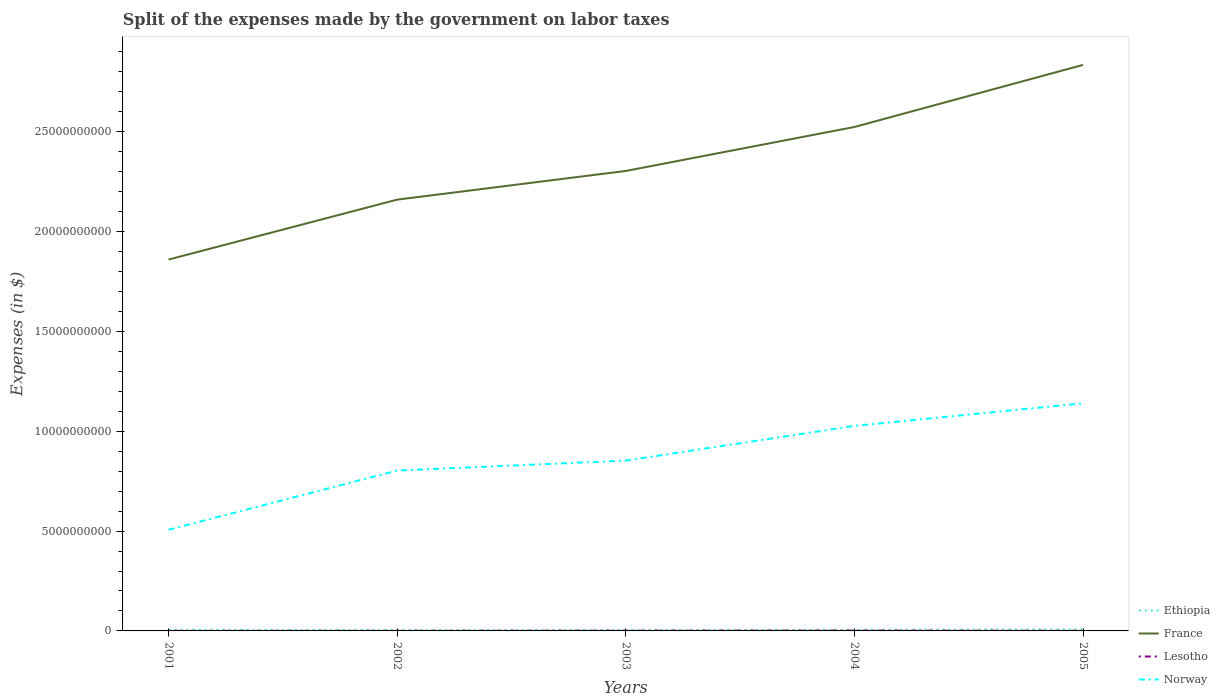How many different coloured lines are there?
Provide a succinct answer. 4. Across all years, what is the maximum expenses made by the government on labor taxes in Norway?
Offer a terse response. 5.07e+09. What is the total expenses made by the government on labor taxes in Ethiopia in the graph?
Provide a short and direct response. -2.00e+07. What is the difference between the highest and the second highest expenses made by the government on labor taxes in Norway?
Your answer should be compact. 6.34e+09. What is the difference between the highest and the lowest expenses made by the government on labor taxes in France?
Provide a short and direct response. 2. Is the expenses made by the government on labor taxes in Ethiopia strictly greater than the expenses made by the government on labor taxes in Norway over the years?
Ensure brevity in your answer.  Yes. How many lines are there?
Provide a short and direct response. 4. Does the graph contain any zero values?
Your answer should be compact. No. Does the graph contain grids?
Make the answer very short. No. Where does the legend appear in the graph?
Provide a short and direct response. Bottom right. How many legend labels are there?
Your answer should be compact. 4. What is the title of the graph?
Offer a very short reply. Split of the expenses made by the government on labor taxes. What is the label or title of the X-axis?
Your response must be concise. Years. What is the label or title of the Y-axis?
Your response must be concise. Expenses (in $). What is the Expenses (in $) in Ethiopia in 2001?
Keep it short and to the point. 5.79e+07. What is the Expenses (in $) of France in 2001?
Your response must be concise. 1.86e+1. What is the Expenses (in $) of Lesotho in 2001?
Ensure brevity in your answer.  5.30e+06. What is the Expenses (in $) of Norway in 2001?
Your response must be concise. 5.07e+09. What is the Expenses (in $) in Ethiopia in 2002?
Ensure brevity in your answer.  4.51e+07. What is the Expenses (in $) in France in 2002?
Ensure brevity in your answer.  2.16e+1. What is the Expenses (in $) in Lesotho in 2002?
Your response must be concise. 6.40e+06. What is the Expenses (in $) in Norway in 2002?
Offer a very short reply. 8.03e+09. What is the Expenses (in $) in Ethiopia in 2003?
Ensure brevity in your answer.  5.20e+07. What is the Expenses (in $) of France in 2003?
Offer a terse response. 2.30e+1. What is the Expenses (in $) of Lesotho in 2003?
Your answer should be compact. 1.05e+07. What is the Expenses (in $) in Norway in 2003?
Your answer should be very brief. 8.53e+09. What is the Expenses (in $) in Ethiopia in 2004?
Provide a succinct answer. 5.71e+07. What is the Expenses (in $) of France in 2004?
Ensure brevity in your answer.  2.52e+1. What is the Expenses (in $) in Lesotho in 2004?
Give a very brief answer. 1.78e+07. What is the Expenses (in $) in Norway in 2004?
Provide a succinct answer. 1.03e+1. What is the Expenses (in $) in Ethiopia in 2005?
Your answer should be very brief. 7.71e+07. What is the Expenses (in $) of France in 2005?
Provide a succinct answer. 2.84e+1. What is the Expenses (in $) of Lesotho in 2005?
Offer a very short reply. 6.74e+06. What is the Expenses (in $) in Norway in 2005?
Ensure brevity in your answer.  1.14e+1. Across all years, what is the maximum Expenses (in $) in Ethiopia?
Your answer should be compact. 7.71e+07. Across all years, what is the maximum Expenses (in $) of France?
Offer a very short reply. 2.84e+1. Across all years, what is the maximum Expenses (in $) of Lesotho?
Your answer should be compact. 1.78e+07. Across all years, what is the maximum Expenses (in $) of Norway?
Offer a terse response. 1.14e+1. Across all years, what is the minimum Expenses (in $) in Ethiopia?
Keep it short and to the point. 4.51e+07. Across all years, what is the minimum Expenses (in $) in France?
Your answer should be very brief. 1.86e+1. Across all years, what is the minimum Expenses (in $) of Lesotho?
Your answer should be compact. 5.30e+06. Across all years, what is the minimum Expenses (in $) in Norway?
Keep it short and to the point. 5.07e+09. What is the total Expenses (in $) of Ethiopia in the graph?
Provide a succinct answer. 2.89e+08. What is the total Expenses (in $) of France in the graph?
Offer a very short reply. 1.17e+11. What is the total Expenses (in $) in Lesotho in the graph?
Your answer should be compact. 4.67e+07. What is the total Expenses (in $) in Norway in the graph?
Offer a very short reply. 4.33e+1. What is the difference between the Expenses (in $) of Ethiopia in 2001 and that in 2002?
Provide a short and direct response. 1.28e+07. What is the difference between the Expenses (in $) of France in 2001 and that in 2002?
Offer a very short reply. -3.00e+09. What is the difference between the Expenses (in $) of Lesotho in 2001 and that in 2002?
Provide a short and direct response. -1.10e+06. What is the difference between the Expenses (in $) of Norway in 2001 and that in 2002?
Your answer should be compact. -2.97e+09. What is the difference between the Expenses (in $) in Ethiopia in 2001 and that in 2003?
Provide a succinct answer. 5.90e+06. What is the difference between the Expenses (in $) in France in 2001 and that in 2003?
Give a very brief answer. -4.44e+09. What is the difference between the Expenses (in $) in Lesotho in 2001 and that in 2003?
Provide a succinct answer. -5.18e+06. What is the difference between the Expenses (in $) in Norway in 2001 and that in 2003?
Offer a very short reply. -3.46e+09. What is the difference between the Expenses (in $) in France in 2001 and that in 2004?
Provide a succinct answer. -6.64e+09. What is the difference between the Expenses (in $) of Lesotho in 2001 and that in 2004?
Offer a terse response. -1.25e+07. What is the difference between the Expenses (in $) of Norway in 2001 and that in 2004?
Your answer should be compact. -5.20e+09. What is the difference between the Expenses (in $) of Ethiopia in 2001 and that in 2005?
Provide a succinct answer. -1.92e+07. What is the difference between the Expenses (in $) in France in 2001 and that in 2005?
Your answer should be compact. -9.75e+09. What is the difference between the Expenses (in $) of Lesotho in 2001 and that in 2005?
Provide a succinct answer. -1.44e+06. What is the difference between the Expenses (in $) of Norway in 2001 and that in 2005?
Your answer should be compact. -6.34e+09. What is the difference between the Expenses (in $) of Ethiopia in 2002 and that in 2003?
Your answer should be very brief. -6.90e+06. What is the difference between the Expenses (in $) in France in 2002 and that in 2003?
Your response must be concise. -1.44e+09. What is the difference between the Expenses (in $) in Lesotho in 2002 and that in 2003?
Ensure brevity in your answer.  -4.08e+06. What is the difference between the Expenses (in $) in Norway in 2002 and that in 2003?
Give a very brief answer. -4.99e+08. What is the difference between the Expenses (in $) of Ethiopia in 2002 and that in 2004?
Your answer should be compact. -1.20e+07. What is the difference between the Expenses (in $) of France in 2002 and that in 2004?
Offer a very short reply. -3.64e+09. What is the difference between the Expenses (in $) in Lesotho in 2002 and that in 2004?
Make the answer very short. -1.14e+07. What is the difference between the Expenses (in $) in Norway in 2002 and that in 2004?
Your answer should be very brief. -2.24e+09. What is the difference between the Expenses (in $) of Ethiopia in 2002 and that in 2005?
Provide a succinct answer. -3.20e+07. What is the difference between the Expenses (in $) in France in 2002 and that in 2005?
Offer a very short reply. -6.75e+09. What is the difference between the Expenses (in $) of Lesotho in 2002 and that in 2005?
Offer a very short reply. -3.35e+05. What is the difference between the Expenses (in $) of Norway in 2002 and that in 2005?
Offer a terse response. -3.37e+09. What is the difference between the Expenses (in $) in Ethiopia in 2003 and that in 2004?
Your answer should be very brief. -5.10e+06. What is the difference between the Expenses (in $) of France in 2003 and that in 2004?
Your answer should be compact. -2.20e+09. What is the difference between the Expenses (in $) of Lesotho in 2003 and that in 2004?
Provide a short and direct response. -7.32e+06. What is the difference between the Expenses (in $) in Norway in 2003 and that in 2004?
Provide a short and direct response. -1.74e+09. What is the difference between the Expenses (in $) in Ethiopia in 2003 and that in 2005?
Give a very brief answer. -2.51e+07. What is the difference between the Expenses (in $) in France in 2003 and that in 2005?
Offer a very short reply. -5.31e+09. What is the difference between the Expenses (in $) of Lesotho in 2003 and that in 2005?
Keep it short and to the point. 3.74e+06. What is the difference between the Expenses (in $) of Norway in 2003 and that in 2005?
Keep it short and to the point. -2.87e+09. What is the difference between the Expenses (in $) in Ethiopia in 2004 and that in 2005?
Provide a short and direct response. -2.00e+07. What is the difference between the Expenses (in $) in France in 2004 and that in 2005?
Give a very brief answer. -3.11e+09. What is the difference between the Expenses (in $) of Lesotho in 2004 and that in 2005?
Ensure brevity in your answer.  1.11e+07. What is the difference between the Expenses (in $) in Norway in 2004 and that in 2005?
Your answer should be very brief. -1.13e+09. What is the difference between the Expenses (in $) in Ethiopia in 2001 and the Expenses (in $) in France in 2002?
Your answer should be very brief. -2.15e+1. What is the difference between the Expenses (in $) in Ethiopia in 2001 and the Expenses (in $) in Lesotho in 2002?
Your answer should be very brief. 5.15e+07. What is the difference between the Expenses (in $) in Ethiopia in 2001 and the Expenses (in $) in Norway in 2002?
Give a very brief answer. -7.98e+09. What is the difference between the Expenses (in $) in France in 2001 and the Expenses (in $) in Lesotho in 2002?
Make the answer very short. 1.86e+1. What is the difference between the Expenses (in $) in France in 2001 and the Expenses (in $) in Norway in 2002?
Offer a terse response. 1.06e+1. What is the difference between the Expenses (in $) of Lesotho in 2001 and the Expenses (in $) of Norway in 2002?
Give a very brief answer. -8.03e+09. What is the difference between the Expenses (in $) of Ethiopia in 2001 and the Expenses (in $) of France in 2003?
Give a very brief answer. -2.30e+1. What is the difference between the Expenses (in $) in Ethiopia in 2001 and the Expenses (in $) in Lesotho in 2003?
Provide a short and direct response. 4.74e+07. What is the difference between the Expenses (in $) in Ethiopia in 2001 and the Expenses (in $) in Norway in 2003?
Offer a very short reply. -8.47e+09. What is the difference between the Expenses (in $) of France in 2001 and the Expenses (in $) of Lesotho in 2003?
Offer a terse response. 1.86e+1. What is the difference between the Expenses (in $) of France in 2001 and the Expenses (in $) of Norway in 2003?
Offer a terse response. 1.01e+1. What is the difference between the Expenses (in $) in Lesotho in 2001 and the Expenses (in $) in Norway in 2003?
Offer a very short reply. -8.53e+09. What is the difference between the Expenses (in $) in Ethiopia in 2001 and the Expenses (in $) in France in 2004?
Give a very brief answer. -2.52e+1. What is the difference between the Expenses (in $) of Ethiopia in 2001 and the Expenses (in $) of Lesotho in 2004?
Make the answer very short. 4.01e+07. What is the difference between the Expenses (in $) in Ethiopia in 2001 and the Expenses (in $) in Norway in 2004?
Offer a terse response. -1.02e+1. What is the difference between the Expenses (in $) in France in 2001 and the Expenses (in $) in Lesotho in 2004?
Your answer should be very brief. 1.86e+1. What is the difference between the Expenses (in $) in France in 2001 and the Expenses (in $) in Norway in 2004?
Your answer should be compact. 8.33e+09. What is the difference between the Expenses (in $) of Lesotho in 2001 and the Expenses (in $) of Norway in 2004?
Make the answer very short. -1.03e+1. What is the difference between the Expenses (in $) of Ethiopia in 2001 and the Expenses (in $) of France in 2005?
Give a very brief answer. -2.83e+1. What is the difference between the Expenses (in $) in Ethiopia in 2001 and the Expenses (in $) in Lesotho in 2005?
Make the answer very short. 5.12e+07. What is the difference between the Expenses (in $) of Ethiopia in 2001 and the Expenses (in $) of Norway in 2005?
Ensure brevity in your answer.  -1.13e+1. What is the difference between the Expenses (in $) in France in 2001 and the Expenses (in $) in Lesotho in 2005?
Provide a succinct answer. 1.86e+1. What is the difference between the Expenses (in $) in France in 2001 and the Expenses (in $) in Norway in 2005?
Provide a short and direct response. 7.20e+09. What is the difference between the Expenses (in $) in Lesotho in 2001 and the Expenses (in $) in Norway in 2005?
Provide a short and direct response. -1.14e+1. What is the difference between the Expenses (in $) in Ethiopia in 2002 and the Expenses (in $) in France in 2003?
Your answer should be very brief. -2.30e+1. What is the difference between the Expenses (in $) of Ethiopia in 2002 and the Expenses (in $) of Lesotho in 2003?
Ensure brevity in your answer.  3.46e+07. What is the difference between the Expenses (in $) of Ethiopia in 2002 and the Expenses (in $) of Norway in 2003?
Give a very brief answer. -8.49e+09. What is the difference between the Expenses (in $) of France in 2002 and the Expenses (in $) of Lesotho in 2003?
Your answer should be very brief. 2.16e+1. What is the difference between the Expenses (in $) of France in 2002 and the Expenses (in $) of Norway in 2003?
Provide a succinct answer. 1.31e+1. What is the difference between the Expenses (in $) of Lesotho in 2002 and the Expenses (in $) of Norway in 2003?
Your answer should be very brief. -8.53e+09. What is the difference between the Expenses (in $) of Ethiopia in 2002 and the Expenses (in $) of France in 2004?
Offer a terse response. -2.52e+1. What is the difference between the Expenses (in $) in Ethiopia in 2002 and the Expenses (in $) in Lesotho in 2004?
Keep it short and to the point. 2.73e+07. What is the difference between the Expenses (in $) in Ethiopia in 2002 and the Expenses (in $) in Norway in 2004?
Provide a short and direct response. -1.02e+1. What is the difference between the Expenses (in $) of France in 2002 and the Expenses (in $) of Lesotho in 2004?
Your answer should be compact. 2.16e+1. What is the difference between the Expenses (in $) of France in 2002 and the Expenses (in $) of Norway in 2004?
Offer a terse response. 1.13e+1. What is the difference between the Expenses (in $) in Lesotho in 2002 and the Expenses (in $) in Norway in 2004?
Make the answer very short. -1.03e+1. What is the difference between the Expenses (in $) of Ethiopia in 2002 and the Expenses (in $) of France in 2005?
Keep it short and to the point. -2.83e+1. What is the difference between the Expenses (in $) of Ethiopia in 2002 and the Expenses (in $) of Lesotho in 2005?
Your response must be concise. 3.84e+07. What is the difference between the Expenses (in $) of Ethiopia in 2002 and the Expenses (in $) of Norway in 2005?
Offer a very short reply. -1.14e+1. What is the difference between the Expenses (in $) of France in 2002 and the Expenses (in $) of Lesotho in 2005?
Make the answer very short. 2.16e+1. What is the difference between the Expenses (in $) of France in 2002 and the Expenses (in $) of Norway in 2005?
Provide a short and direct response. 1.02e+1. What is the difference between the Expenses (in $) of Lesotho in 2002 and the Expenses (in $) of Norway in 2005?
Give a very brief answer. -1.14e+1. What is the difference between the Expenses (in $) of Ethiopia in 2003 and the Expenses (in $) of France in 2004?
Ensure brevity in your answer.  -2.52e+1. What is the difference between the Expenses (in $) of Ethiopia in 2003 and the Expenses (in $) of Lesotho in 2004?
Make the answer very short. 3.42e+07. What is the difference between the Expenses (in $) in Ethiopia in 2003 and the Expenses (in $) in Norway in 2004?
Your answer should be very brief. -1.02e+1. What is the difference between the Expenses (in $) in France in 2003 and the Expenses (in $) in Lesotho in 2004?
Provide a succinct answer. 2.30e+1. What is the difference between the Expenses (in $) of France in 2003 and the Expenses (in $) of Norway in 2004?
Make the answer very short. 1.28e+1. What is the difference between the Expenses (in $) in Lesotho in 2003 and the Expenses (in $) in Norway in 2004?
Offer a very short reply. -1.03e+1. What is the difference between the Expenses (in $) in Ethiopia in 2003 and the Expenses (in $) in France in 2005?
Provide a short and direct response. -2.83e+1. What is the difference between the Expenses (in $) in Ethiopia in 2003 and the Expenses (in $) in Lesotho in 2005?
Offer a very short reply. 4.53e+07. What is the difference between the Expenses (in $) of Ethiopia in 2003 and the Expenses (in $) of Norway in 2005?
Provide a short and direct response. -1.14e+1. What is the difference between the Expenses (in $) in France in 2003 and the Expenses (in $) in Lesotho in 2005?
Your answer should be very brief. 2.30e+1. What is the difference between the Expenses (in $) of France in 2003 and the Expenses (in $) of Norway in 2005?
Your answer should be very brief. 1.16e+1. What is the difference between the Expenses (in $) of Lesotho in 2003 and the Expenses (in $) of Norway in 2005?
Provide a short and direct response. -1.14e+1. What is the difference between the Expenses (in $) in Ethiopia in 2004 and the Expenses (in $) in France in 2005?
Offer a very short reply. -2.83e+1. What is the difference between the Expenses (in $) in Ethiopia in 2004 and the Expenses (in $) in Lesotho in 2005?
Your response must be concise. 5.04e+07. What is the difference between the Expenses (in $) of Ethiopia in 2004 and the Expenses (in $) of Norway in 2005?
Your answer should be very brief. -1.13e+1. What is the difference between the Expenses (in $) in France in 2004 and the Expenses (in $) in Lesotho in 2005?
Provide a short and direct response. 2.52e+1. What is the difference between the Expenses (in $) of France in 2004 and the Expenses (in $) of Norway in 2005?
Your answer should be compact. 1.38e+1. What is the difference between the Expenses (in $) of Lesotho in 2004 and the Expenses (in $) of Norway in 2005?
Your answer should be very brief. -1.14e+1. What is the average Expenses (in $) of Ethiopia per year?
Offer a terse response. 5.78e+07. What is the average Expenses (in $) of France per year?
Ensure brevity in your answer.  2.34e+1. What is the average Expenses (in $) in Lesotho per year?
Your answer should be compact. 9.34e+06. What is the average Expenses (in $) of Norway per year?
Make the answer very short. 8.66e+09. In the year 2001, what is the difference between the Expenses (in $) of Ethiopia and Expenses (in $) of France?
Your answer should be very brief. -1.85e+1. In the year 2001, what is the difference between the Expenses (in $) of Ethiopia and Expenses (in $) of Lesotho?
Your answer should be very brief. 5.26e+07. In the year 2001, what is the difference between the Expenses (in $) of Ethiopia and Expenses (in $) of Norway?
Offer a very short reply. -5.01e+09. In the year 2001, what is the difference between the Expenses (in $) of France and Expenses (in $) of Lesotho?
Provide a succinct answer. 1.86e+1. In the year 2001, what is the difference between the Expenses (in $) in France and Expenses (in $) in Norway?
Make the answer very short. 1.35e+1. In the year 2001, what is the difference between the Expenses (in $) in Lesotho and Expenses (in $) in Norway?
Offer a very short reply. -5.06e+09. In the year 2002, what is the difference between the Expenses (in $) in Ethiopia and Expenses (in $) in France?
Your answer should be compact. -2.16e+1. In the year 2002, what is the difference between the Expenses (in $) of Ethiopia and Expenses (in $) of Lesotho?
Keep it short and to the point. 3.87e+07. In the year 2002, what is the difference between the Expenses (in $) in Ethiopia and Expenses (in $) in Norway?
Give a very brief answer. -7.99e+09. In the year 2002, what is the difference between the Expenses (in $) of France and Expenses (in $) of Lesotho?
Your response must be concise. 2.16e+1. In the year 2002, what is the difference between the Expenses (in $) in France and Expenses (in $) in Norway?
Make the answer very short. 1.36e+1. In the year 2002, what is the difference between the Expenses (in $) in Lesotho and Expenses (in $) in Norway?
Your response must be concise. -8.03e+09. In the year 2003, what is the difference between the Expenses (in $) in Ethiopia and Expenses (in $) in France?
Offer a very short reply. -2.30e+1. In the year 2003, what is the difference between the Expenses (in $) of Ethiopia and Expenses (in $) of Lesotho?
Provide a succinct answer. 4.15e+07. In the year 2003, what is the difference between the Expenses (in $) of Ethiopia and Expenses (in $) of Norway?
Keep it short and to the point. -8.48e+09. In the year 2003, what is the difference between the Expenses (in $) of France and Expenses (in $) of Lesotho?
Ensure brevity in your answer.  2.30e+1. In the year 2003, what is the difference between the Expenses (in $) of France and Expenses (in $) of Norway?
Make the answer very short. 1.45e+1. In the year 2003, what is the difference between the Expenses (in $) of Lesotho and Expenses (in $) of Norway?
Provide a short and direct response. -8.52e+09. In the year 2004, what is the difference between the Expenses (in $) of Ethiopia and Expenses (in $) of France?
Provide a succinct answer. -2.52e+1. In the year 2004, what is the difference between the Expenses (in $) in Ethiopia and Expenses (in $) in Lesotho?
Make the answer very short. 3.93e+07. In the year 2004, what is the difference between the Expenses (in $) in Ethiopia and Expenses (in $) in Norway?
Keep it short and to the point. -1.02e+1. In the year 2004, what is the difference between the Expenses (in $) of France and Expenses (in $) of Lesotho?
Your answer should be very brief. 2.52e+1. In the year 2004, what is the difference between the Expenses (in $) of France and Expenses (in $) of Norway?
Provide a succinct answer. 1.50e+1. In the year 2004, what is the difference between the Expenses (in $) of Lesotho and Expenses (in $) of Norway?
Give a very brief answer. -1.03e+1. In the year 2005, what is the difference between the Expenses (in $) in Ethiopia and Expenses (in $) in France?
Ensure brevity in your answer.  -2.83e+1. In the year 2005, what is the difference between the Expenses (in $) in Ethiopia and Expenses (in $) in Lesotho?
Your answer should be compact. 7.04e+07. In the year 2005, what is the difference between the Expenses (in $) of Ethiopia and Expenses (in $) of Norway?
Provide a succinct answer. -1.13e+1. In the year 2005, what is the difference between the Expenses (in $) in France and Expenses (in $) in Lesotho?
Your answer should be compact. 2.83e+1. In the year 2005, what is the difference between the Expenses (in $) of France and Expenses (in $) of Norway?
Your answer should be compact. 1.70e+1. In the year 2005, what is the difference between the Expenses (in $) in Lesotho and Expenses (in $) in Norway?
Provide a succinct answer. -1.14e+1. What is the ratio of the Expenses (in $) in Ethiopia in 2001 to that in 2002?
Keep it short and to the point. 1.28. What is the ratio of the Expenses (in $) of France in 2001 to that in 2002?
Keep it short and to the point. 0.86. What is the ratio of the Expenses (in $) in Lesotho in 2001 to that in 2002?
Make the answer very short. 0.83. What is the ratio of the Expenses (in $) in Norway in 2001 to that in 2002?
Give a very brief answer. 0.63. What is the ratio of the Expenses (in $) of Ethiopia in 2001 to that in 2003?
Ensure brevity in your answer.  1.11. What is the ratio of the Expenses (in $) in France in 2001 to that in 2003?
Ensure brevity in your answer.  0.81. What is the ratio of the Expenses (in $) of Lesotho in 2001 to that in 2003?
Your response must be concise. 0.51. What is the ratio of the Expenses (in $) in Norway in 2001 to that in 2003?
Your answer should be very brief. 0.59. What is the ratio of the Expenses (in $) of France in 2001 to that in 2004?
Keep it short and to the point. 0.74. What is the ratio of the Expenses (in $) in Lesotho in 2001 to that in 2004?
Your response must be concise. 0.3. What is the ratio of the Expenses (in $) in Norway in 2001 to that in 2004?
Your response must be concise. 0.49. What is the ratio of the Expenses (in $) in Ethiopia in 2001 to that in 2005?
Make the answer very short. 0.75. What is the ratio of the Expenses (in $) in France in 2001 to that in 2005?
Give a very brief answer. 0.66. What is the ratio of the Expenses (in $) of Lesotho in 2001 to that in 2005?
Your answer should be compact. 0.79. What is the ratio of the Expenses (in $) of Norway in 2001 to that in 2005?
Your answer should be very brief. 0.44. What is the ratio of the Expenses (in $) in Ethiopia in 2002 to that in 2003?
Your response must be concise. 0.87. What is the ratio of the Expenses (in $) in France in 2002 to that in 2003?
Give a very brief answer. 0.94. What is the ratio of the Expenses (in $) in Lesotho in 2002 to that in 2003?
Your response must be concise. 0.61. What is the ratio of the Expenses (in $) of Norway in 2002 to that in 2003?
Give a very brief answer. 0.94. What is the ratio of the Expenses (in $) of Ethiopia in 2002 to that in 2004?
Make the answer very short. 0.79. What is the ratio of the Expenses (in $) in France in 2002 to that in 2004?
Offer a terse response. 0.86. What is the ratio of the Expenses (in $) of Lesotho in 2002 to that in 2004?
Offer a terse response. 0.36. What is the ratio of the Expenses (in $) in Norway in 2002 to that in 2004?
Your response must be concise. 0.78. What is the ratio of the Expenses (in $) of Ethiopia in 2002 to that in 2005?
Your response must be concise. 0.58. What is the ratio of the Expenses (in $) of France in 2002 to that in 2005?
Provide a short and direct response. 0.76. What is the ratio of the Expenses (in $) in Lesotho in 2002 to that in 2005?
Your answer should be very brief. 0.95. What is the ratio of the Expenses (in $) in Norway in 2002 to that in 2005?
Give a very brief answer. 0.7. What is the ratio of the Expenses (in $) in Ethiopia in 2003 to that in 2004?
Offer a terse response. 0.91. What is the ratio of the Expenses (in $) of France in 2003 to that in 2004?
Your response must be concise. 0.91. What is the ratio of the Expenses (in $) of Lesotho in 2003 to that in 2004?
Your answer should be very brief. 0.59. What is the ratio of the Expenses (in $) in Norway in 2003 to that in 2004?
Provide a short and direct response. 0.83. What is the ratio of the Expenses (in $) of Ethiopia in 2003 to that in 2005?
Offer a very short reply. 0.67. What is the ratio of the Expenses (in $) in France in 2003 to that in 2005?
Offer a terse response. 0.81. What is the ratio of the Expenses (in $) in Lesotho in 2003 to that in 2005?
Your answer should be compact. 1.56. What is the ratio of the Expenses (in $) in Norway in 2003 to that in 2005?
Your response must be concise. 0.75. What is the ratio of the Expenses (in $) of Ethiopia in 2004 to that in 2005?
Keep it short and to the point. 0.74. What is the ratio of the Expenses (in $) of France in 2004 to that in 2005?
Give a very brief answer. 0.89. What is the ratio of the Expenses (in $) in Lesotho in 2004 to that in 2005?
Ensure brevity in your answer.  2.64. What is the ratio of the Expenses (in $) in Norway in 2004 to that in 2005?
Offer a terse response. 0.9. What is the difference between the highest and the second highest Expenses (in $) in Ethiopia?
Offer a terse response. 1.92e+07. What is the difference between the highest and the second highest Expenses (in $) of France?
Provide a succinct answer. 3.11e+09. What is the difference between the highest and the second highest Expenses (in $) of Lesotho?
Make the answer very short. 7.32e+06. What is the difference between the highest and the second highest Expenses (in $) of Norway?
Ensure brevity in your answer.  1.13e+09. What is the difference between the highest and the lowest Expenses (in $) in Ethiopia?
Keep it short and to the point. 3.20e+07. What is the difference between the highest and the lowest Expenses (in $) of France?
Offer a very short reply. 9.75e+09. What is the difference between the highest and the lowest Expenses (in $) in Lesotho?
Keep it short and to the point. 1.25e+07. What is the difference between the highest and the lowest Expenses (in $) of Norway?
Provide a succinct answer. 6.34e+09. 